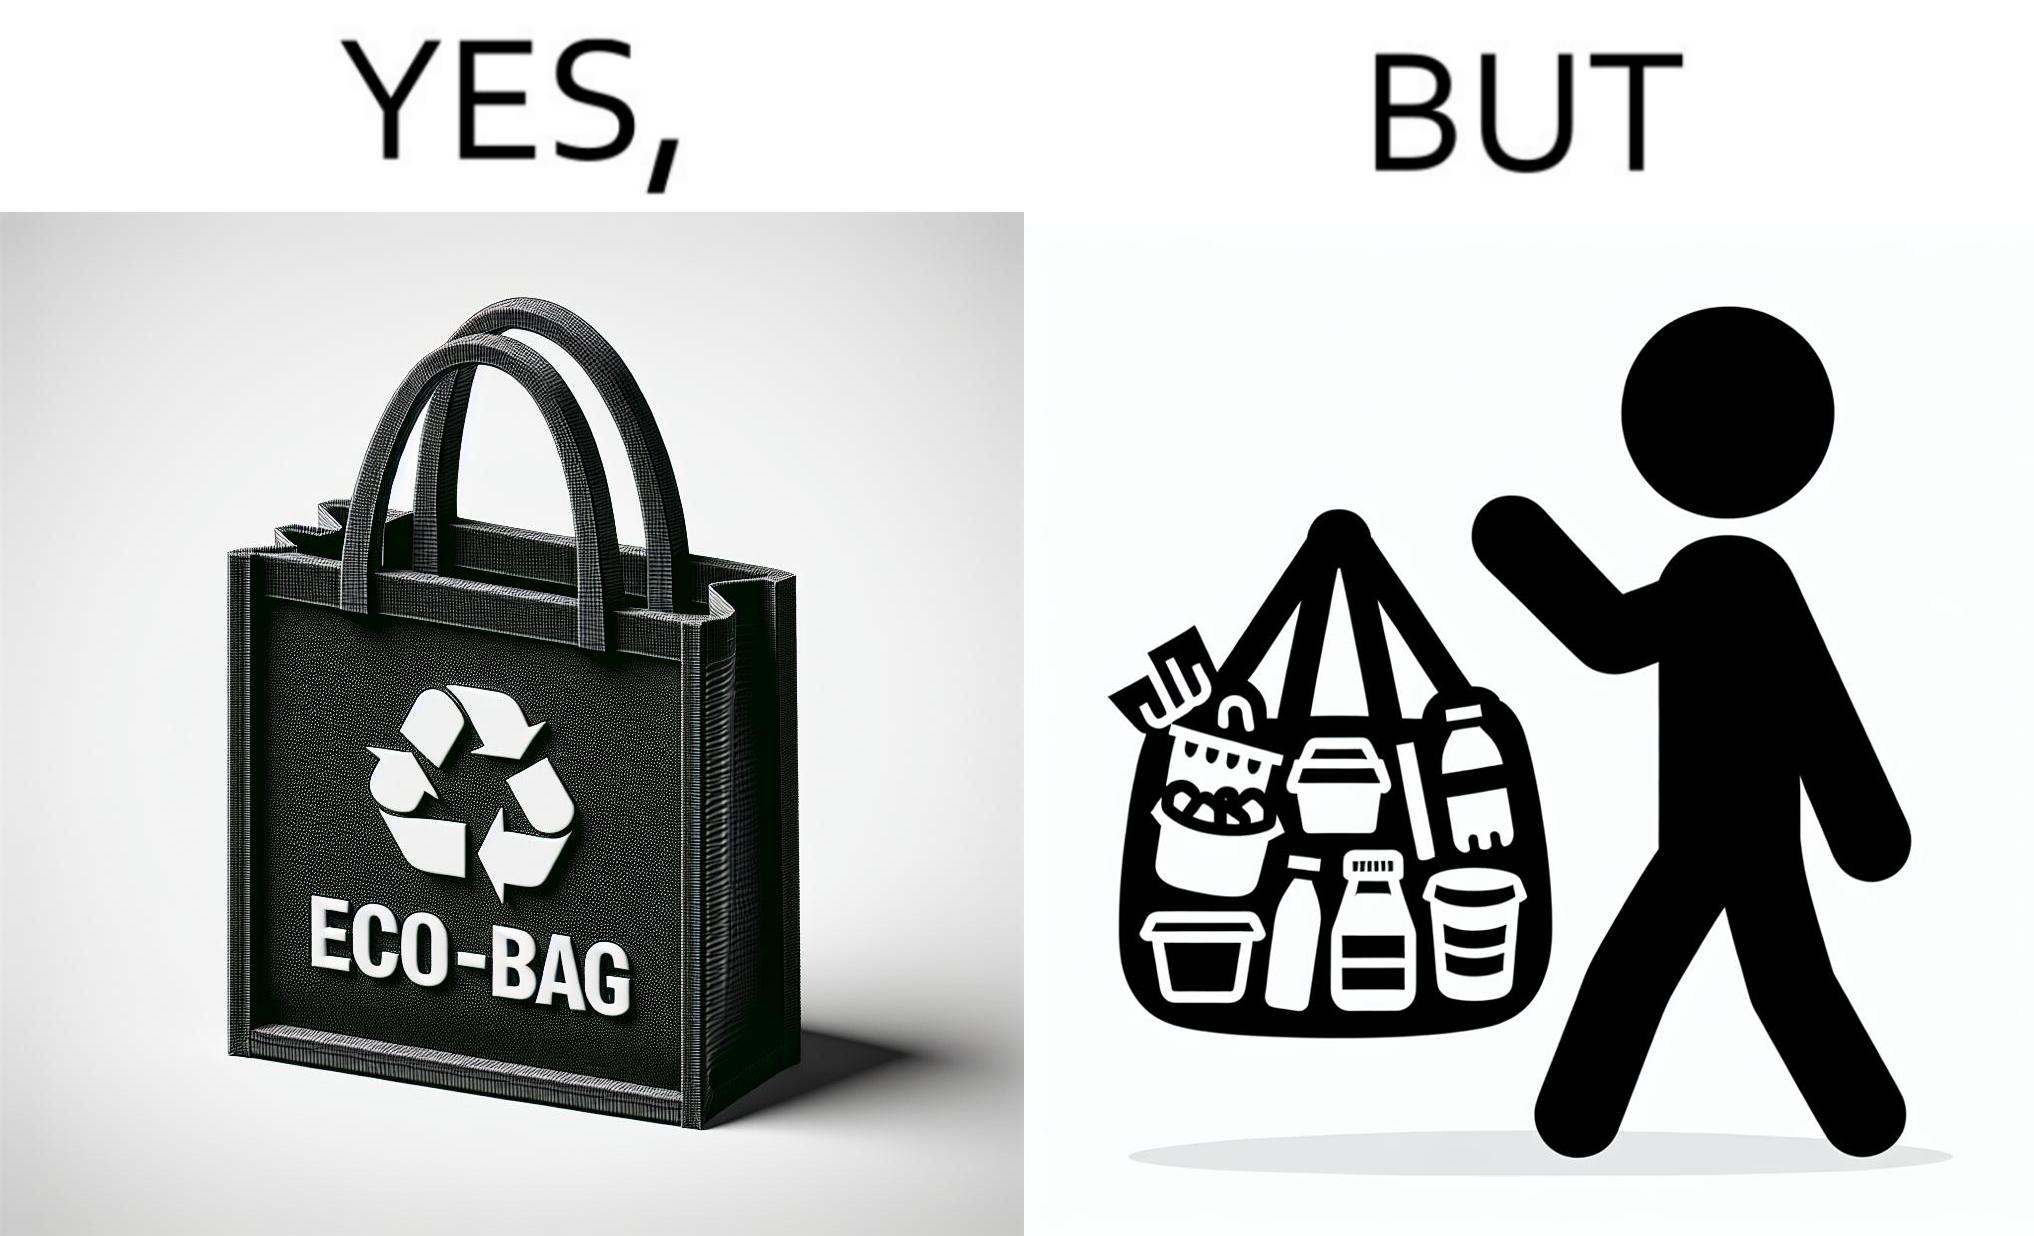What makes this image funny or satirical? The image is ironic, because people nowadays use eco-bag thinking them as safe for the environment but in turn use products which are harmful for the environment or are packaged in some non-biodegradable material 